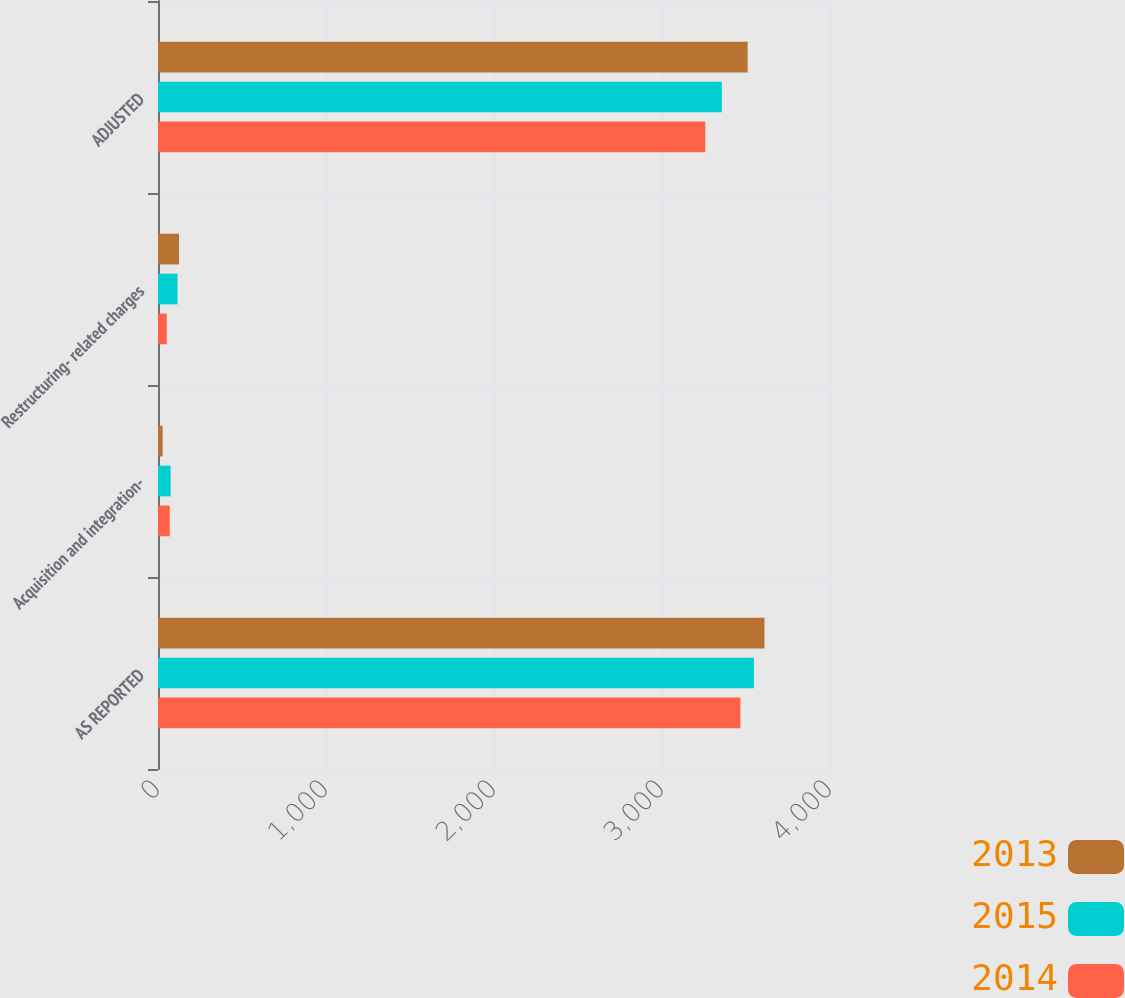Convert chart to OTSL. <chart><loc_0><loc_0><loc_500><loc_500><stacked_bar_chart><ecel><fcel>AS REPORTED<fcel>Acquisition and integration-<fcel>Restructuring- related charges<fcel>ADJUSTED<nl><fcel>2013<fcel>3610<fcel>28<fcel>125<fcel>3510<nl><fcel>2015<fcel>3547<fcel>75<fcel>116<fcel>3356<nl><fcel>2014<fcel>3467<fcel>70<fcel>52<fcel>3258<nl></chart> 